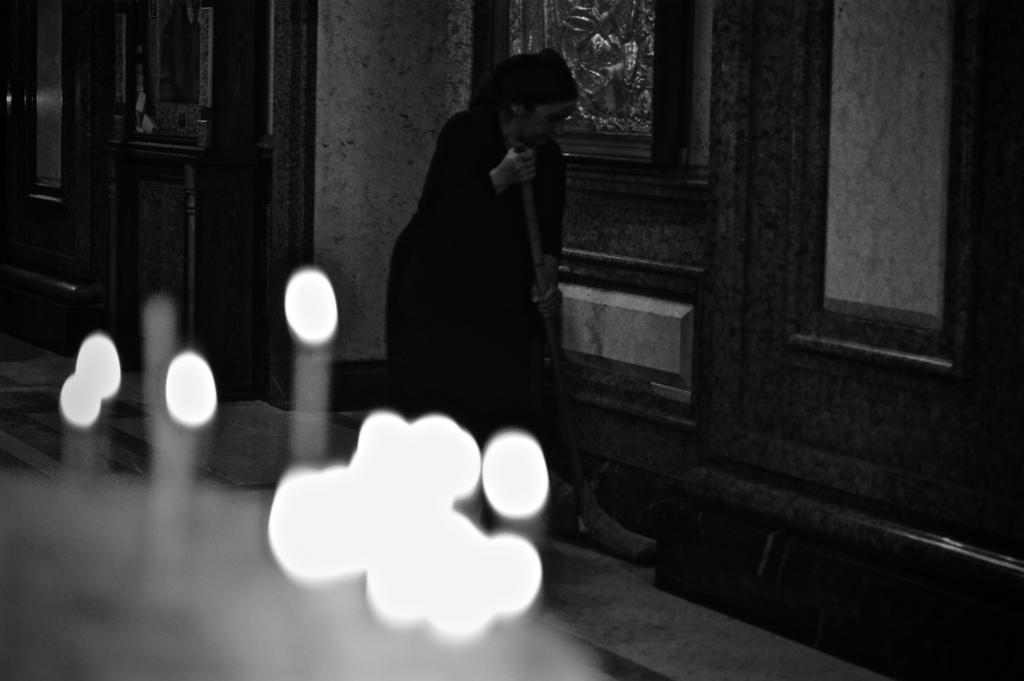Who is the main subject in the image? There is a woman in the image. What is the woman doing in the image? The woman is holding an object with her hands on the floor. What can be seen in the background of the image? There is a wall in the background of the image. What type of lighting is present in the image? There are lights visible in the image. What type of plant is the woman watering in the image? There is no plant visible in the image, and the woman is not shown watering anything. What decision is the robin making in the image? There is no robin present in the image, so no decision can be attributed to it. 